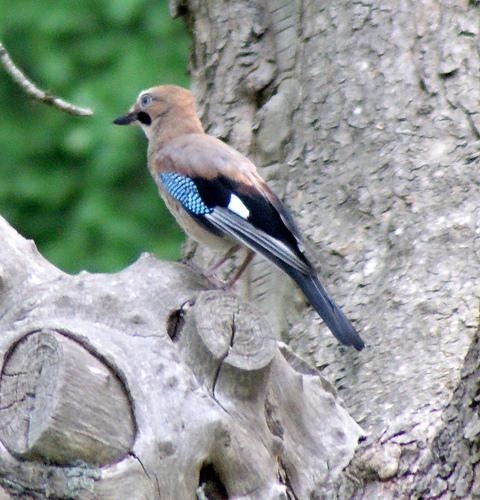Question: who is standing next to the bird?
Choices:
A. A woman.
B. A child.
C. No one.
D. The young man.
Answer with the letter. Answer: C Question: where was this photo taken?
Choices:
A. On a pole.
B. At a light.
C. On a tree.
D. Under an umbrella.
Answer with the letter. Answer: C Question: what animal is seen in this photo?
Choices:
A. Mouse.
B. Bird.
C. Cat.
D. Dog.
Answer with the letter. Answer: B 